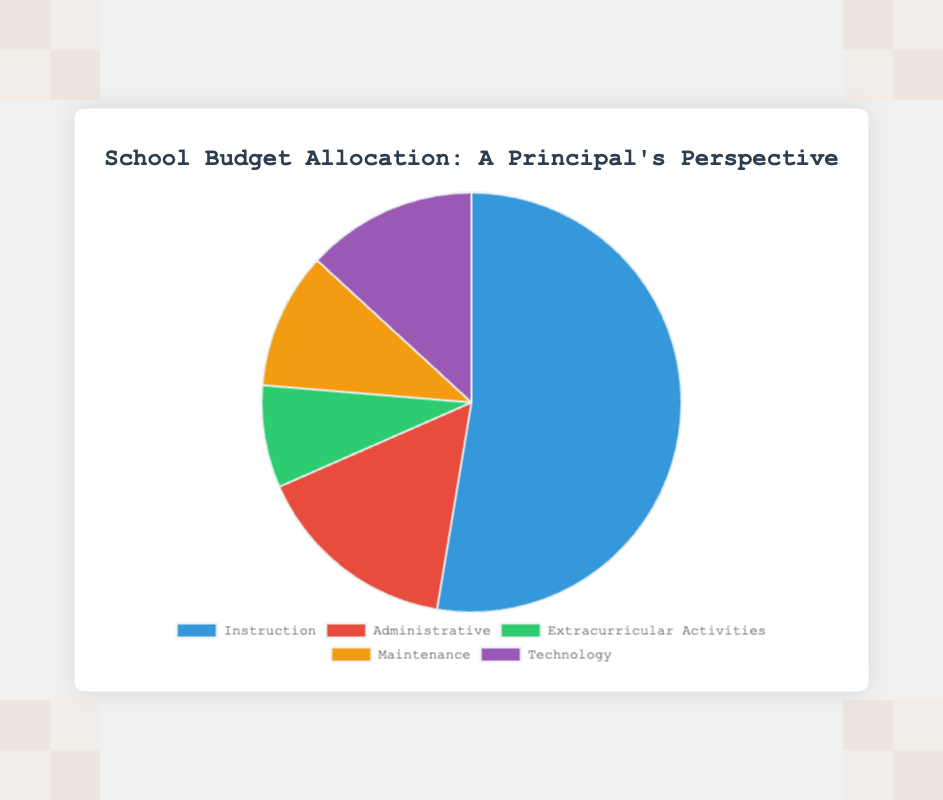What percentage of the budget is allocated to Instruction? To find the percentage, divide the amount for Instruction by the total budget and multiply by 100. Total budget = 500000 + 150000 + 75000 + 100000 + 125000 = 950000. The percentage is (500000 / 950000) * 100 ≈ 52.63%.
Answer: 52.63% Which department receives the least amount of funding? Compare the funding amounts for each department. Extracurricular Activities receive the least funding at 75000.
Answer: Extracurricular Activities How much more funding does Instruction receive compared to Technology? Subtract the funding for Technology from the funding for Instruction. 500000 - 125000 = 375000.
Answer: 375000 What is the combined budget for Administrative and Maintenance departments? Add the amounts for Administrative and Maintenance. 150000 + 100000 = 250000.
Answer: 250000 Which segment is represented by the green color in the pie chart? Identify the department associated with the green section of the pie chart. Green represents Extracurricular Activities.
Answer: Extracurricular Activities If the total budget were increased by 10%, how much would the new total budget be? Find 10% of the total current budget and add it to the current total budget. 10% of 950000 is 95000. New total = 950000 + 95000 = 1045000.
Answer: 1045000 What percentage of the budget is allocated to Maintenance and Technology combined? First, find the combined budget for Maintenance and Technology and then calculate the percentage. Combined budget = 100000 + 125000 = 225000. The percentage is (225000 / 950000) * 100 ≈ 23.68%.
Answer: 23.68% Is the budget for Administrative greater than for Extracurricular Activities? Compare the amounts for Administrative and Extracurricular Activities. Administrative (150000) is greater than Extracurricular Activities (75000).
Answer: Yes Which department's funding represents approximately 13% of the total budget? Calculate the percentage for each department and compare. Technology’s budget (125000) represents approximately (125000 / 950000) * 100 ≈ 13.16%.
Answer: Technology 